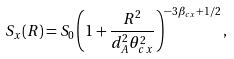Convert formula to latex. <formula><loc_0><loc_0><loc_500><loc_500>S _ { x } ( R ) = S _ { 0 } \left ( 1 + \frac { R ^ { 2 } } { d _ { A } ^ { 2 } \theta _ { c x } ^ { 2 } } \right ) ^ { - 3 \beta _ { c x } + 1 / 2 } ,</formula> 